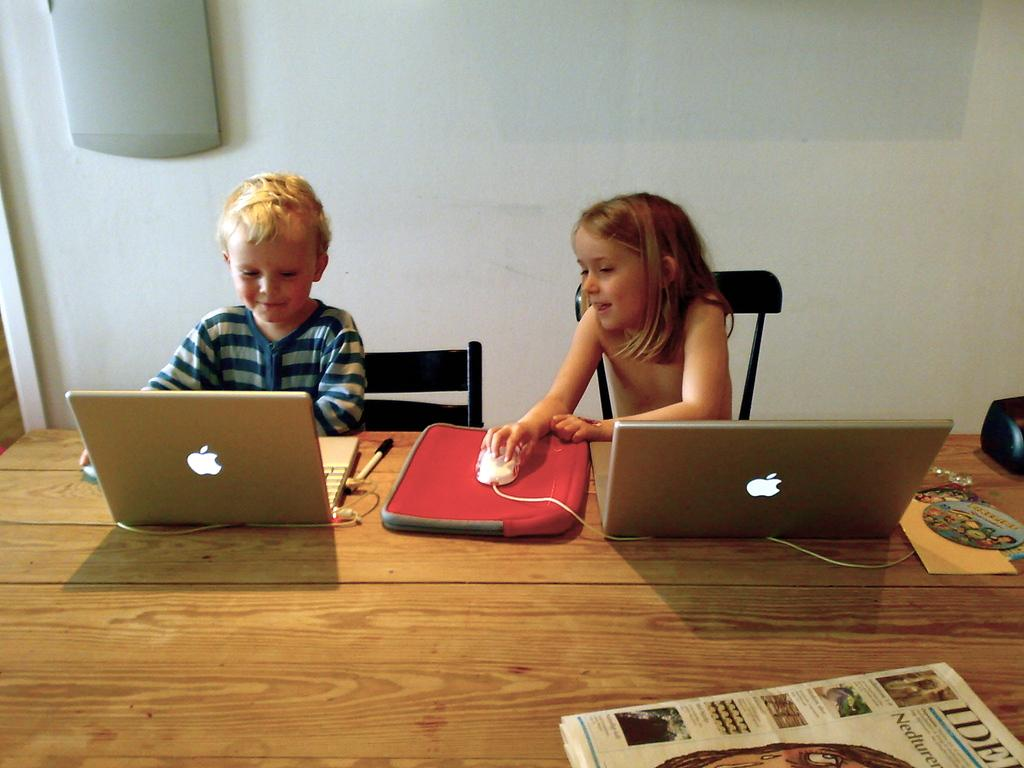How many children are in the image? There are two children in the image. What are the children doing in the image? The children are sitting on chairs. What is on the table in the image? There are laptops, a mouse, and a paper on the table. What is visible in the background of the image? There is a wall in the background of the image. What type of trees can be seen in the cemetery in the image? There is no cemetery or trees present in the image. Can you tell me which map is being used by the children in the image? There is no map visible in the image. 